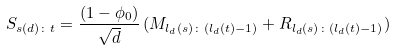Convert formula to latex. <formula><loc_0><loc_0><loc_500><loc_500>S _ { s ( d ) \colon t } = \frac { ( 1 - \phi _ { 0 } ) } { \sqrt { d } } \, ( M _ { l _ { d } ( s ) \colon ( l _ { d } ( t ) - 1 ) } + R _ { l _ { d } ( s ) \colon ( l _ { d } ( t ) - 1 ) } )</formula> 